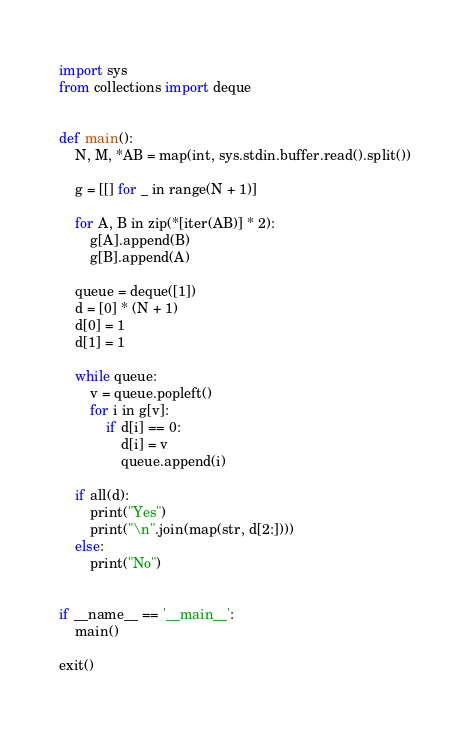<code> <loc_0><loc_0><loc_500><loc_500><_Python_>import sys
from collections import deque


def main():
    N, M, *AB = map(int, sys.stdin.buffer.read().split())
    
    g = [[] for _ in range(N + 1)]

    for A, B in zip(*[iter(AB)] * 2):
        g[A].append(B)
        g[B].append(A)

    queue = deque([1])
    d = [0] * (N + 1)
    d[0] = 1
    d[1] = 1

    while queue:
        v = queue.popleft()
        for i in g[v]:
            if d[i] == 0:
                d[i] = v
                queue.append(i)

    if all(d):
        print("Yes")
        print("\n".join(map(str, d[2:])))
    else:
        print("No")


if __name__ == '__main__':
	main()

exit()
</code> 